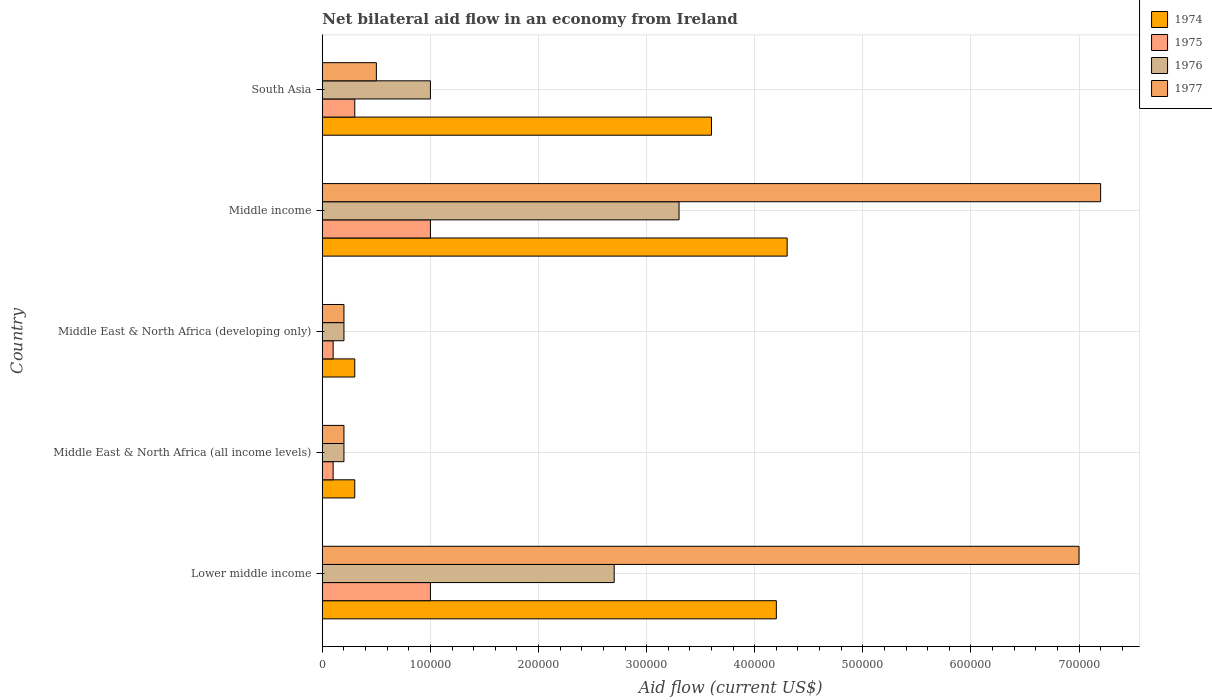Are the number of bars per tick equal to the number of legend labels?
Give a very brief answer. Yes. Are the number of bars on each tick of the Y-axis equal?
Ensure brevity in your answer.  Yes. How many bars are there on the 4th tick from the top?
Offer a very short reply. 4. How many bars are there on the 2nd tick from the bottom?
Your answer should be very brief. 4. What is the label of the 5th group of bars from the top?
Make the answer very short. Lower middle income. In how many cases, is the number of bars for a given country not equal to the number of legend labels?
Offer a terse response. 0. Across all countries, what is the maximum net bilateral aid flow in 1977?
Provide a short and direct response. 7.20e+05. In which country was the net bilateral aid flow in 1974 maximum?
Your response must be concise. Middle income. In which country was the net bilateral aid flow in 1974 minimum?
Ensure brevity in your answer.  Middle East & North Africa (all income levels). What is the total net bilateral aid flow in 1976 in the graph?
Give a very brief answer. 7.40e+05. What is the difference between the net bilateral aid flow in 1974 in Lower middle income and that in Middle income?
Offer a very short reply. -10000. What is the difference between the net bilateral aid flow in 1976 in Middle income and the net bilateral aid flow in 1974 in Middle East & North Africa (developing only)?
Provide a short and direct response. 3.00e+05. What is the average net bilateral aid flow in 1977 per country?
Offer a very short reply. 3.02e+05. What is the difference between the net bilateral aid flow in 1974 and net bilateral aid flow in 1977 in Lower middle income?
Give a very brief answer. -2.80e+05. In how many countries, is the net bilateral aid flow in 1977 greater than 520000 US$?
Give a very brief answer. 2. Is the net bilateral aid flow in 1974 in Middle East & North Africa (developing only) less than that in South Asia?
Offer a very short reply. Yes. Is the difference between the net bilateral aid flow in 1974 in Lower middle income and Middle East & North Africa (developing only) greater than the difference between the net bilateral aid flow in 1977 in Lower middle income and Middle East & North Africa (developing only)?
Make the answer very short. No. What is the difference between the highest and the second highest net bilateral aid flow in 1976?
Provide a succinct answer. 6.00e+04. What is the difference between the highest and the lowest net bilateral aid flow in 1974?
Your answer should be compact. 4.00e+05. Is the sum of the net bilateral aid flow in 1976 in Lower middle income and Middle East & North Africa (developing only) greater than the maximum net bilateral aid flow in 1974 across all countries?
Your answer should be very brief. No. What does the 3rd bar from the top in Middle East & North Africa (all income levels) represents?
Ensure brevity in your answer.  1975. What does the 1st bar from the bottom in Lower middle income represents?
Make the answer very short. 1974. Is it the case that in every country, the sum of the net bilateral aid flow in 1975 and net bilateral aid flow in 1974 is greater than the net bilateral aid flow in 1976?
Your answer should be compact. Yes. How many countries are there in the graph?
Offer a very short reply. 5. What is the difference between two consecutive major ticks on the X-axis?
Your response must be concise. 1.00e+05. Are the values on the major ticks of X-axis written in scientific E-notation?
Your response must be concise. No. Does the graph contain any zero values?
Provide a succinct answer. No. Where does the legend appear in the graph?
Provide a short and direct response. Top right. How many legend labels are there?
Your answer should be compact. 4. What is the title of the graph?
Keep it short and to the point. Net bilateral aid flow in an economy from Ireland. Does "1974" appear as one of the legend labels in the graph?
Your response must be concise. Yes. What is the label or title of the X-axis?
Keep it short and to the point. Aid flow (current US$). What is the Aid flow (current US$) in 1975 in Lower middle income?
Your response must be concise. 1.00e+05. What is the Aid flow (current US$) in 1974 in Middle East & North Africa (all income levels)?
Give a very brief answer. 3.00e+04. What is the Aid flow (current US$) in 1976 in Middle East & North Africa (all income levels)?
Your answer should be very brief. 2.00e+04. What is the Aid flow (current US$) of 1977 in Middle East & North Africa (all income levels)?
Your answer should be very brief. 2.00e+04. What is the Aid flow (current US$) in 1976 in Middle East & North Africa (developing only)?
Offer a very short reply. 2.00e+04. What is the Aid flow (current US$) in 1977 in Middle East & North Africa (developing only)?
Make the answer very short. 2.00e+04. What is the Aid flow (current US$) in 1974 in Middle income?
Provide a succinct answer. 4.30e+05. What is the Aid flow (current US$) of 1977 in Middle income?
Offer a very short reply. 7.20e+05. What is the Aid flow (current US$) of 1974 in South Asia?
Your response must be concise. 3.60e+05. What is the Aid flow (current US$) in 1976 in South Asia?
Provide a short and direct response. 1.00e+05. Across all countries, what is the maximum Aid flow (current US$) in 1974?
Keep it short and to the point. 4.30e+05. Across all countries, what is the maximum Aid flow (current US$) of 1977?
Ensure brevity in your answer.  7.20e+05. Across all countries, what is the minimum Aid flow (current US$) of 1976?
Provide a short and direct response. 2.00e+04. Across all countries, what is the minimum Aid flow (current US$) of 1977?
Provide a succinct answer. 2.00e+04. What is the total Aid flow (current US$) in 1974 in the graph?
Give a very brief answer. 1.27e+06. What is the total Aid flow (current US$) of 1975 in the graph?
Offer a terse response. 2.50e+05. What is the total Aid flow (current US$) in 1976 in the graph?
Offer a terse response. 7.40e+05. What is the total Aid flow (current US$) in 1977 in the graph?
Offer a terse response. 1.51e+06. What is the difference between the Aid flow (current US$) of 1977 in Lower middle income and that in Middle East & North Africa (all income levels)?
Your answer should be compact. 6.80e+05. What is the difference between the Aid flow (current US$) of 1975 in Lower middle income and that in Middle East & North Africa (developing only)?
Offer a very short reply. 9.00e+04. What is the difference between the Aid flow (current US$) of 1977 in Lower middle income and that in Middle East & North Africa (developing only)?
Ensure brevity in your answer.  6.80e+05. What is the difference between the Aid flow (current US$) of 1975 in Lower middle income and that in Middle income?
Offer a terse response. 0. What is the difference between the Aid flow (current US$) in 1976 in Lower middle income and that in Middle income?
Offer a very short reply. -6.00e+04. What is the difference between the Aid flow (current US$) in 1977 in Lower middle income and that in South Asia?
Provide a succinct answer. 6.50e+05. What is the difference between the Aid flow (current US$) in 1974 in Middle East & North Africa (all income levels) and that in Middle East & North Africa (developing only)?
Keep it short and to the point. 0. What is the difference between the Aid flow (current US$) in 1976 in Middle East & North Africa (all income levels) and that in Middle East & North Africa (developing only)?
Give a very brief answer. 0. What is the difference between the Aid flow (current US$) in 1974 in Middle East & North Africa (all income levels) and that in Middle income?
Ensure brevity in your answer.  -4.00e+05. What is the difference between the Aid flow (current US$) of 1976 in Middle East & North Africa (all income levels) and that in Middle income?
Your answer should be compact. -3.10e+05. What is the difference between the Aid flow (current US$) in 1977 in Middle East & North Africa (all income levels) and that in Middle income?
Make the answer very short. -7.00e+05. What is the difference between the Aid flow (current US$) in 1974 in Middle East & North Africa (all income levels) and that in South Asia?
Make the answer very short. -3.30e+05. What is the difference between the Aid flow (current US$) in 1975 in Middle East & North Africa (all income levels) and that in South Asia?
Give a very brief answer. -2.00e+04. What is the difference between the Aid flow (current US$) of 1976 in Middle East & North Africa (all income levels) and that in South Asia?
Your answer should be compact. -8.00e+04. What is the difference between the Aid flow (current US$) of 1974 in Middle East & North Africa (developing only) and that in Middle income?
Your response must be concise. -4.00e+05. What is the difference between the Aid flow (current US$) of 1976 in Middle East & North Africa (developing only) and that in Middle income?
Offer a terse response. -3.10e+05. What is the difference between the Aid flow (current US$) of 1977 in Middle East & North Africa (developing only) and that in Middle income?
Your answer should be compact. -7.00e+05. What is the difference between the Aid flow (current US$) of 1974 in Middle East & North Africa (developing only) and that in South Asia?
Give a very brief answer. -3.30e+05. What is the difference between the Aid flow (current US$) in 1975 in Middle East & North Africa (developing only) and that in South Asia?
Your answer should be compact. -2.00e+04. What is the difference between the Aid flow (current US$) of 1977 in Middle East & North Africa (developing only) and that in South Asia?
Make the answer very short. -3.00e+04. What is the difference between the Aid flow (current US$) of 1974 in Middle income and that in South Asia?
Your answer should be very brief. 7.00e+04. What is the difference between the Aid flow (current US$) in 1975 in Middle income and that in South Asia?
Your answer should be very brief. 7.00e+04. What is the difference between the Aid flow (current US$) in 1976 in Middle income and that in South Asia?
Provide a short and direct response. 2.30e+05. What is the difference between the Aid flow (current US$) in 1977 in Middle income and that in South Asia?
Keep it short and to the point. 6.70e+05. What is the difference between the Aid flow (current US$) of 1974 in Lower middle income and the Aid flow (current US$) of 1976 in Middle East & North Africa (all income levels)?
Provide a succinct answer. 4.00e+05. What is the difference between the Aid flow (current US$) of 1974 in Lower middle income and the Aid flow (current US$) of 1977 in Middle East & North Africa (all income levels)?
Offer a terse response. 4.00e+05. What is the difference between the Aid flow (current US$) of 1975 in Lower middle income and the Aid flow (current US$) of 1977 in Middle East & North Africa (all income levels)?
Your answer should be compact. 8.00e+04. What is the difference between the Aid flow (current US$) of 1974 in Lower middle income and the Aid flow (current US$) of 1975 in Middle East & North Africa (developing only)?
Make the answer very short. 4.10e+05. What is the difference between the Aid flow (current US$) of 1974 in Lower middle income and the Aid flow (current US$) of 1977 in Middle East & North Africa (developing only)?
Your response must be concise. 4.00e+05. What is the difference between the Aid flow (current US$) in 1975 in Lower middle income and the Aid flow (current US$) in 1976 in Middle East & North Africa (developing only)?
Provide a short and direct response. 8.00e+04. What is the difference between the Aid flow (current US$) of 1975 in Lower middle income and the Aid flow (current US$) of 1977 in Middle East & North Africa (developing only)?
Your answer should be compact. 8.00e+04. What is the difference between the Aid flow (current US$) in 1974 in Lower middle income and the Aid flow (current US$) in 1975 in Middle income?
Your answer should be compact. 3.20e+05. What is the difference between the Aid flow (current US$) in 1975 in Lower middle income and the Aid flow (current US$) in 1976 in Middle income?
Keep it short and to the point. -2.30e+05. What is the difference between the Aid flow (current US$) in 1975 in Lower middle income and the Aid flow (current US$) in 1977 in Middle income?
Provide a succinct answer. -6.20e+05. What is the difference between the Aid flow (current US$) in 1976 in Lower middle income and the Aid flow (current US$) in 1977 in Middle income?
Your answer should be compact. -4.50e+05. What is the difference between the Aid flow (current US$) in 1974 in Lower middle income and the Aid flow (current US$) in 1975 in South Asia?
Give a very brief answer. 3.90e+05. What is the difference between the Aid flow (current US$) of 1974 in Lower middle income and the Aid flow (current US$) of 1976 in South Asia?
Provide a succinct answer. 3.20e+05. What is the difference between the Aid flow (current US$) of 1974 in Lower middle income and the Aid flow (current US$) of 1977 in South Asia?
Your answer should be compact. 3.70e+05. What is the difference between the Aid flow (current US$) of 1974 in Middle East & North Africa (all income levels) and the Aid flow (current US$) of 1975 in Middle East & North Africa (developing only)?
Make the answer very short. 2.00e+04. What is the difference between the Aid flow (current US$) in 1974 in Middle East & North Africa (all income levels) and the Aid flow (current US$) in 1976 in Middle East & North Africa (developing only)?
Provide a short and direct response. 10000. What is the difference between the Aid flow (current US$) in 1975 in Middle East & North Africa (all income levels) and the Aid flow (current US$) in 1976 in Middle East & North Africa (developing only)?
Offer a terse response. -10000. What is the difference between the Aid flow (current US$) in 1975 in Middle East & North Africa (all income levels) and the Aid flow (current US$) in 1977 in Middle East & North Africa (developing only)?
Offer a very short reply. -10000. What is the difference between the Aid flow (current US$) in 1974 in Middle East & North Africa (all income levels) and the Aid flow (current US$) in 1977 in Middle income?
Your answer should be compact. -6.90e+05. What is the difference between the Aid flow (current US$) in 1975 in Middle East & North Africa (all income levels) and the Aid flow (current US$) in 1976 in Middle income?
Offer a terse response. -3.20e+05. What is the difference between the Aid flow (current US$) in 1975 in Middle East & North Africa (all income levels) and the Aid flow (current US$) in 1977 in Middle income?
Provide a succinct answer. -7.10e+05. What is the difference between the Aid flow (current US$) of 1976 in Middle East & North Africa (all income levels) and the Aid flow (current US$) of 1977 in Middle income?
Offer a terse response. -7.00e+05. What is the difference between the Aid flow (current US$) of 1974 in Middle East & North Africa (all income levels) and the Aid flow (current US$) of 1976 in South Asia?
Offer a terse response. -7.00e+04. What is the difference between the Aid flow (current US$) of 1974 in Middle East & North Africa (all income levels) and the Aid flow (current US$) of 1977 in South Asia?
Make the answer very short. -2.00e+04. What is the difference between the Aid flow (current US$) of 1974 in Middle East & North Africa (developing only) and the Aid flow (current US$) of 1977 in Middle income?
Your response must be concise. -6.90e+05. What is the difference between the Aid flow (current US$) of 1975 in Middle East & North Africa (developing only) and the Aid flow (current US$) of 1976 in Middle income?
Your response must be concise. -3.20e+05. What is the difference between the Aid flow (current US$) in 1975 in Middle East & North Africa (developing only) and the Aid flow (current US$) in 1977 in Middle income?
Your answer should be very brief. -7.10e+05. What is the difference between the Aid flow (current US$) of 1976 in Middle East & North Africa (developing only) and the Aid flow (current US$) of 1977 in Middle income?
Offer a terse response. -7.00e+05. What is the difference between the Aid flow (current US$) of 1974 in Middle East & North Africa (developing only) and the Aid flow (current US$) of 1976 in South Asia?
Provide a short and direct response. -7.00e+04. What is the difference between the Aid flow (current US$) in 1975 in Middle East & North Africa (developing only) and the Aid flow (current US$) in 1976 in South Asia?
Ensure brevity in your answer.  -9.00e+04. What is the difference between the Aid flow (current US$) of 1975 in Middle East & North Africa (developing only) and the Aid flow (current US$) of 1977 in South Asia?
Offer a terse response. -4.00e+04. What is the difference between the Aid flow (current US$) of 1976 in Middle East & North Africa (developing only) and the Aid flow (current US$) of 1977 in South Asia?
Keep it short and to the point. -3.00e+04. What is the difference between the Aid flow (current US$) of 1974 in Middle income and the Aid flow (current US$) of 1976 in South Asia?
Offer a terse response. 3.30e+05. What is the difference between the Aid flow (current US$) in 1974 in Middle income and the Aid flow (current US$) in 1977 in South Asia?
Keep it short and to the point. 3.80e+05. What is the difference between the Aid flow (current US$) in 1975 in Middle income and the Aid flow (current US$) in 1976 in South Asia?
Provide a short and direct response. 0. What is the difference between the Aid flow (current US$) of 1975 in Middle income and the Aid flow (current US$) of 1977 in South Asia?
Ensure brevity in your answer.  5.00e+04. What is the difference between the Aid flow (current US$) in 1976 in Middle income and the Aid flow (current US$) in 1977 in South Asia?
Offer a very short reply. 2.80e+05. What is the average Aid flow (current US$) in 1974 per country?
Offer a very short reply. 2.54e+05. What is the average Aid flow (current US$) in 1976 per country?
Offer a terse response. 1.48e+05. What is the average Aid flow (current US$) of 1977 per country?
Your response must be concise. 3.02e+05. What is the difference between the Aid flow (current US$) of 1974 and Aid flow (current US$) of 1976 in Lower middle income?
Give a very brief answer. 1.50e+05. What is the difference between the Aid flow (current US$) in 1974 and Aid flow (current US$) in 1977 in Lower middle income?
Provide a succinct answer. -2.80e+05. What is the difference between the Aid flow (current US$) of 1975 and Aid flow (current US$) of 1976 in Lower middle income?
Offer a very short reply. -1.70e+05. What is the difference between the Aid flow (current US$) in 1975 and Aid flow (current US$) in 1977 in Lower middle income?
Ensure brevity in your answer.  -6.00e+05. What is the difference between the Aid flow (current US$) of 1976 and Aid flow (current US$) of 1977 in Lower middle income?
Ensure brevity in your answer.  -4.30e+05. What is the difference between the Aid flow (current US$) in 1974 and Aid flow (current US$) in 1975 in Middle East & North Africa (all income levels)?
Offer a very short reply. 2.00e+04. What is the difference between the Aid flow (current US$) in 1974 and Aid flow (current US$) in 1976 in Middle East & North Africa (all income levels)?
Provide a short and direct response. 10000. What is the difference between the Aid flow (current US$) in 1976 and Aid flow (current US$) in 1977 in Middle East & North Africa (all income levels)?
Your answer should be very brief. 0. What is the difference between the Aid flow (current US$) of 1974 and Aid flow (current US$) of 1975 in Middle East & North Africa (developing only)?
Your answer should be very brief. 2.00e+04. What is the difference between the Aid flow (current US$) of 1974 and Aid flow (current US$) of 1975 in Middle income?
Offer a terse response. 3.30e+05. What is the difference between the Aid flow (current US$) in 1975 and Aid flow (current US$) in 1976 in Middle income?
Your answer should be very brief. -2.30e+05. What is the difference between the Aid flow (current US$) in 1975 and Aid flow (current US$) in 1977 in Middle income?
Provide a succinct answer. -6.20e+05. What is the difference between the Aid flow (current US$) of 1976 and Aid flow (current US$) of 1977 in Middle income?
Make the answer very short. -3.90e+05. What is the difference between the Aid flow (current US$) in 1974 and Aid flow (current US$) in 1976 in South Asia?
Your answer should be very brief. 2.60e+05. What is the difference between the Aid flow (current US$) of 1974 and Aid flow (current US$) of 1977 in South Asia?
Give a very brief answer. 3.10e+05. What is the difference between the Aid flow (current US$) of 1975 and Aid flow (current US$) of 1976 in South Asia?
Provide a succinct answer. -7.00e+04. What is the ratio of the Aid flow (current US$) in 1974 in Lower middle income to that in Middle East & North Africa (developing only)?
Make the answer very short. 14. What is the ratio of the Aid flow (current US$) in 1975 in Lower middle income to that in Middle East & North Africa (developing only)?
Your response must be concise. 10. What is the ratio of the Aid flow (current US$) in 1974 in Lower middle income to that in Middle income?
Provide a succinct answer. 0.98. What is the ratio of the Aid flow (current US$) of 1975 in Lower middle income to that in Middle income?
Keep it short and to the point. 1. What is the ratio of the Aid flow (current US$) of 1976 in Lower middle income to that in Middle income?
Your answer should be very brief. 0.82. What is the ratio of the Aid flow (current US$) in 1977 in Lower middle income to that in Middle income?
Ensure brevity in your answer.  0.97. What is the ratio of the Aid flow (current US$) in 1975 in Lower middle income to that in South Asia?
Your response must be concise. 3.33. What is the ratio of the Aid flow (current US$) of 1976 in Lower middle income to that in South Asia?
Keep it short and to the point. 2.7. What is the ratio of the Aid flow (current US$) of 1975 in Middle East & North Africa (all income levels) to that in Middle East & North Africa (developing only)?
Keep it short and to the point. 1. What is the ratio of the Aid flow (current US$) of 1974 in Middle East & North Africa (all income levels) to that in Middle income?
Provide a short and direct response. 0.07. What is the ratio of the Aid flow (current US$) in 1976 in Middle East & North Africa (all income levels) to that in Middle income?
Keep it short and to the point. 0.06. What is the ratio of the Aid flow (current US$) of 1977 in Middle East & North Africa (all income levels) to that in Middle income?
Provide a short and direct response. 0.03. What is the ratio of the Aid flow (current US$) in 1974 in Middle East & North Africa (all income levels) to that in South Asia?
Your response must be concise. 0.08. What is the ratio of the Aid flow (current US$) in 1976 in Middle East & North Africa (all income levels) to that in South Asia?
Give a very brief answer. 0.2. What is the ratio of the Aid flow (current US$) of 1977 in Middle East & North Africa (all income levels) to that in South Asia?
Offer a terse response. 0.4. What is the ratio of the Aid flow (current US$) of 1974 in Middle East & North Africa (developing only) to that in Middle income?
Offer a very short reply. 0.07. What is the ratio of the Aid flow (current US$) in 1975 in Middle East & North Africa (developing only) to that in Middle income?
Provide a succinct answer. 0.1. What is the ratio of the Aid flow (current US$) of 1976 in Middle East & North Africa (developing only) to that in Middle income?
Give a very brief answer. 0.06. What is the ratio of the Aid flow (current US$) of 1977 in Middle East & North Africa (developing only) to that in Middle income?
Your answer should be very brief. 0.03. What is the ratio of the Aid flow (current US$) of 1974 in Middle East & North Africa (developing only) to that in South Asia?
Keep it short and to the point. 0.08. What is the ratio of the Aid flow (current US$) of 1975 in Middle East & North Africa (developing only) to that in South Asia?
Ensure brevity in your answer.  0.33. What is the ratio of the Aid flow (current US$) in 1976 in Middle East & North Africa (developing only) to that in South Asia?
Your answer should be very brief. 0.2. What is the ratio of the Aid flow (current US$) in 1977 in Middle East & North Africa (developing only) to that in South Asia?
Your response must be concise. 0.4. What is the ratio of the Aid flow (current US$) of 1974 in Middle income to that in South Asia?
Make the answer very short. 1.19. What is the ratio of the Aid flow (current US$) of 1976 in Middle income to that in South Asia?
Provide a succinct answer. 3.3. What is the difference between the highest and the second highest Aid flow (current US$) in 1974?
Provide a succinct answer. 10000. What is the difference between the highest and the second highest Aid flow (current US$) of 1976?
Make the answer very short. 6.00e+04. What is the difference between the highest and the lowest Aid flow (current US$) of 1974?
Offer a terse response. 4.00e+05. What is the difference between the highest and the lowest Aid flow (current US$) of 1975?
Offer a very short reply. 9.00e+04. What is the difference between the highest and the lowest Aid flow (current US$) of 1976?
Give a very brief answer. 3.10e+05. 